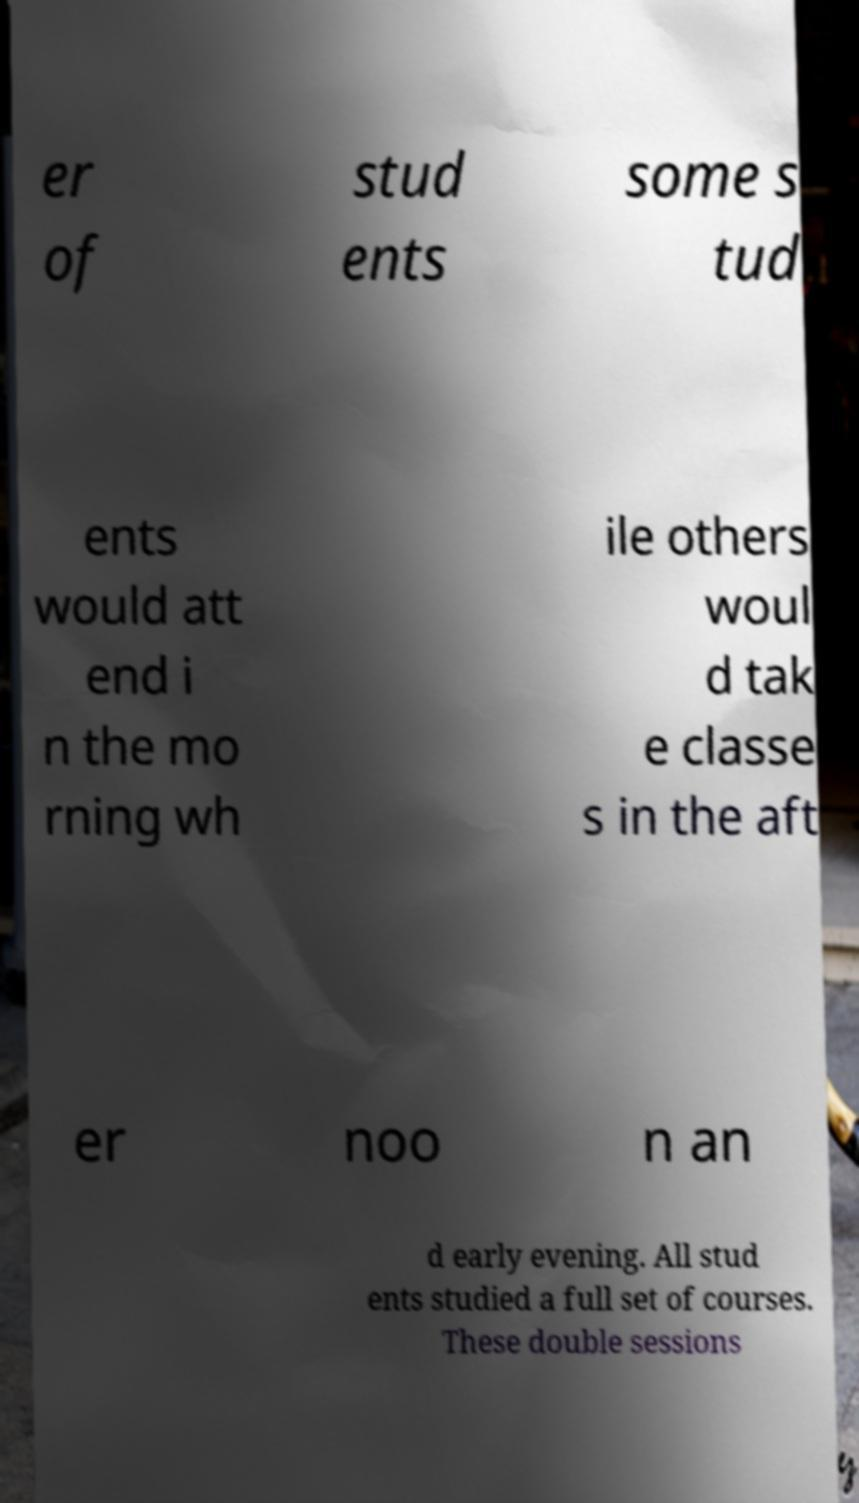What messages or text are displayed in this image? I need them in a readable, typed format. er of stud ents some s tud ents would att end i n the mo rning wh ile others woul d tak e classe s in the aft er noo n an d early evening. All stud ents studied a full set of courses. These double sessions 